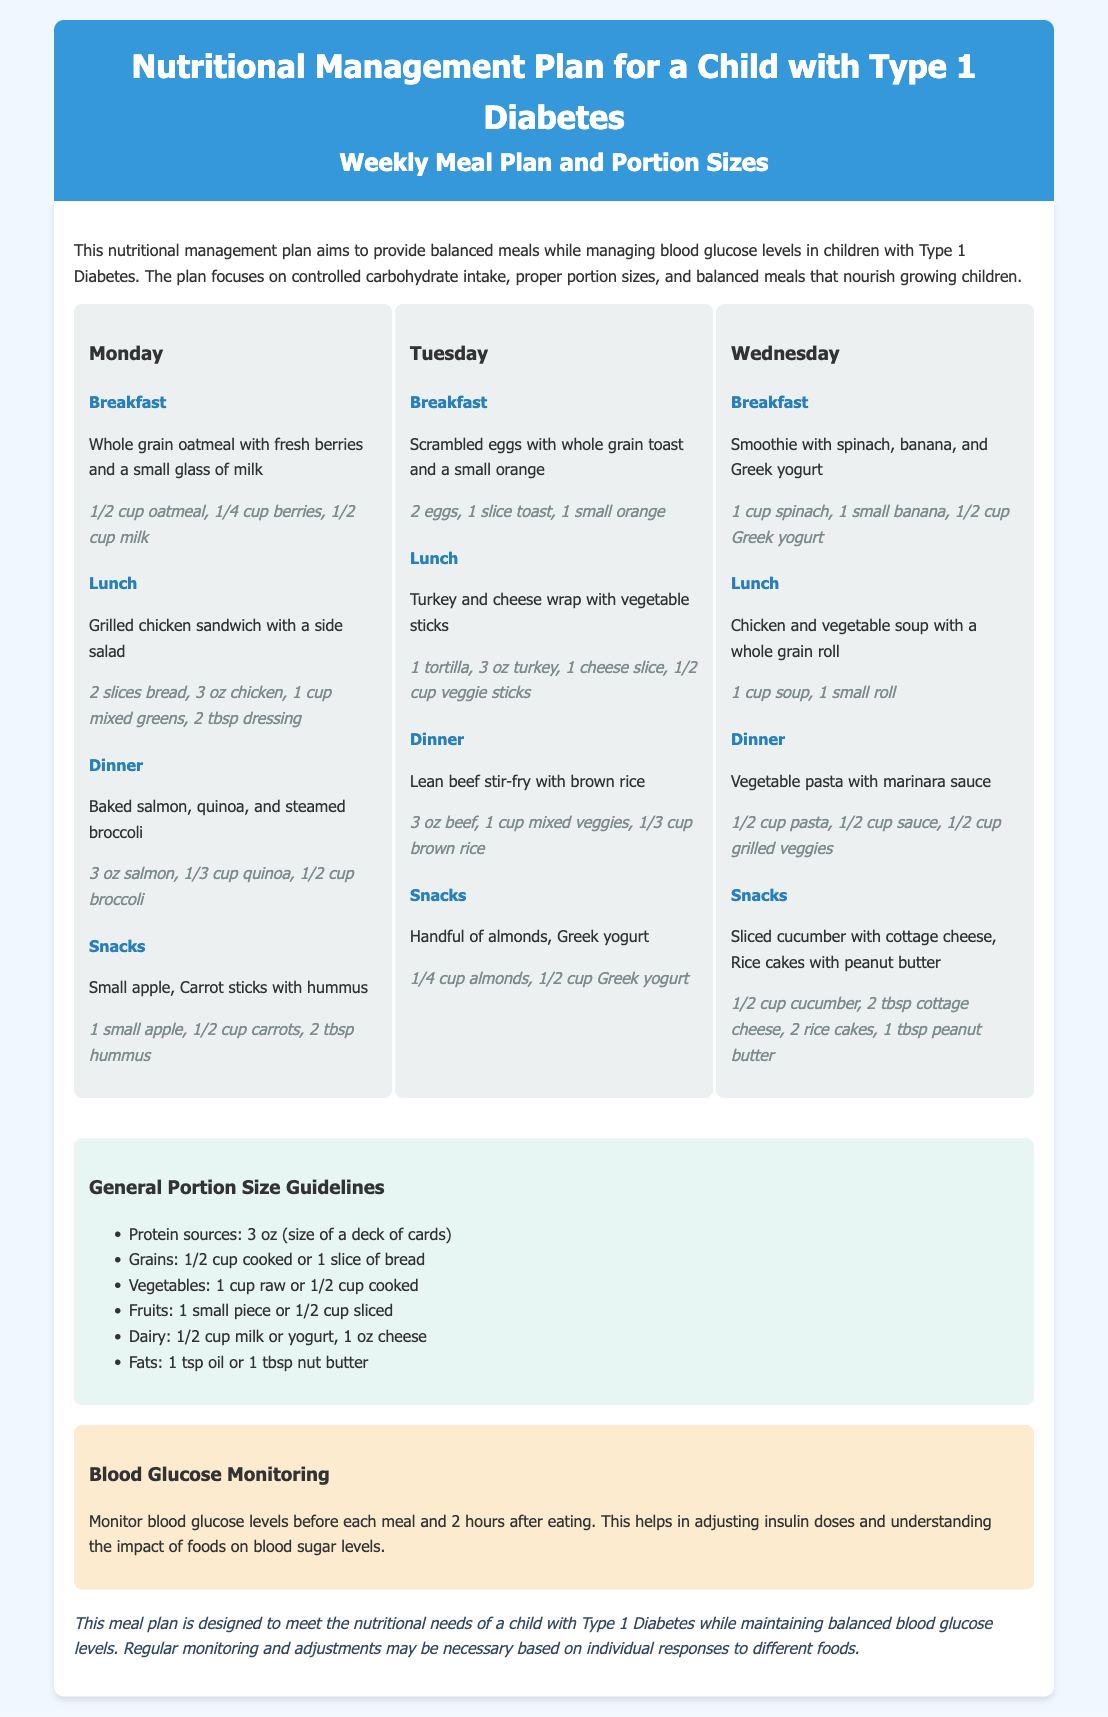what is the maximum portion size for protein sources? The document states that protein sources should be 3 oz, which is the size of a deck of cards.
Answer: 3 oz what should be monitored before each meal? The document emphasizes the importance of monitoring blood glucose levels before each meal.
Answer: blood glucose levels what is included in breakfast on Monday? The breakfast on Monday consists of whole grain oatmeal with fresh berries and a small glass of milk.
Answer: whole grain oatmeal, fresh berries, small glass of milk how many calories are provided by the apple snack? The document does not specify the caloric content of snacks, focusing instead on portion sizes. Therefore, this question cannot be answered with current information.
Answer: not specified what type of dairy is consumed during Tuesday's snacks? Tuesday's snacks include Greek yogurt as a dairy option.
Answer: Greek yogurt which meal includes quinoa? The dinner on Monday includes baked salmon, quinoa, and steamed broccoli.
Answer: dinner on Monday how many eggs are recommended for breakfast on Tuesday? Breakfast on Tuesday recommends 2 eggs.
Answer: 2 eggs what does the general portion size guideline say for grains? The guideline states that grains should be 1/2 cup cooked or 1 slice of bread.
Answer: 1/2 cup cooked or 1 slice of bread 